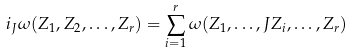<formula> <loc_0><loc_0><loc_500><loc_500>i _ { J } \omega ( Z _ { 1 } , Z _ { 2 } , \dots , Z _ { r } ) = \sum _ { i = 1 } ^ { r } \omega ( Z _ { 1 } , \dots , J Z _ { i } , \dots , Z _ { r } )</formula> 